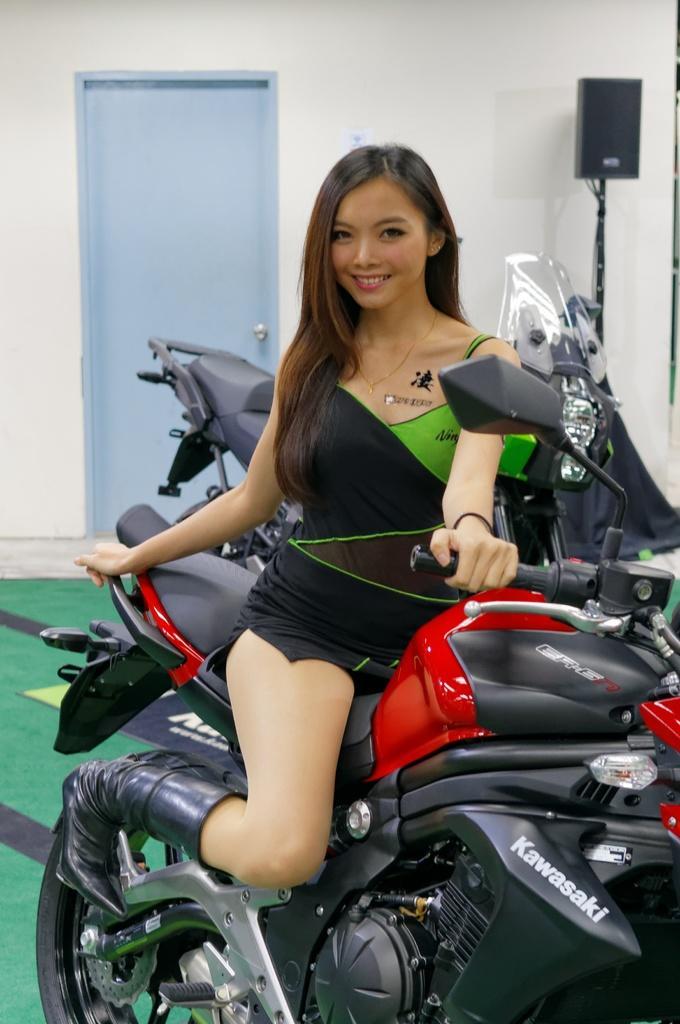Describe this image in one or two sentences. In this image i can see a woman sitting on a motor bike and in the background i can see another motor bike, a door and a wall with speaker. 